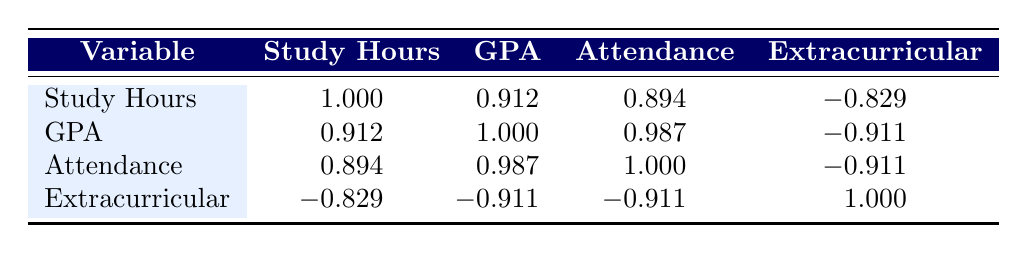What is the correlation coefficient between study hours and GPA? From the table, the correlation coefficient between study hours and GPA is indicated in the row for Study Hours and the column for GPA as 0.912.
Answer: 0.912 Is there a strong positive correlation between attendance percentage and GPA? The correlation coefficient between attendance percentage and GPA is 0.987, which is very close to 1, indicating a strong positive correlation.
Answer: Yes What is the correlation coefficient for the relationship between extracurricular hours and study hours? The correlation coefficient between extracurricular hours and study hours is -0.829, which indicates a strong negative correlation.
Answer: -0.829 How does the correlation coefficient between study hours and attendance percentage compare to that between GPA and attendance percentage? The correlation between study hours and attendance percentage is 0.894, while the correlation between GPA and attendance percentage is 0.987. The GPA and attendance correlation is stronger.
Answer: GPA and attendance correlation is stronger What would be the average of the correlation coefficients involving GPA? The correlations involving GPA are: Study Hours (0.912), Attendance (0.987), and Extracurricular (-0.911). To find the average: (0.912 + 0.987 - 0.911) / 3 = 0.329.
Answer: 0.329 